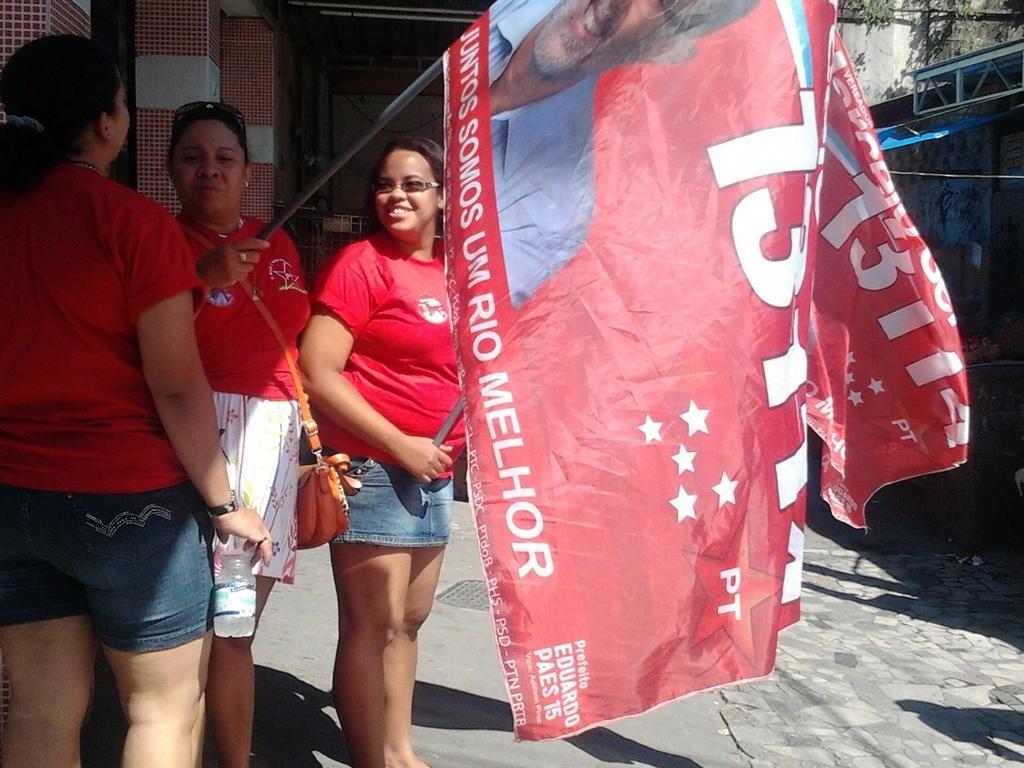Can you describe this image briefly? In this image I can see three persons standing. In the middle the person is holding the banner and the banner is in red color. Background I can see few pillars and I can see few trees in green color and the person is wearing red and white color dress. 